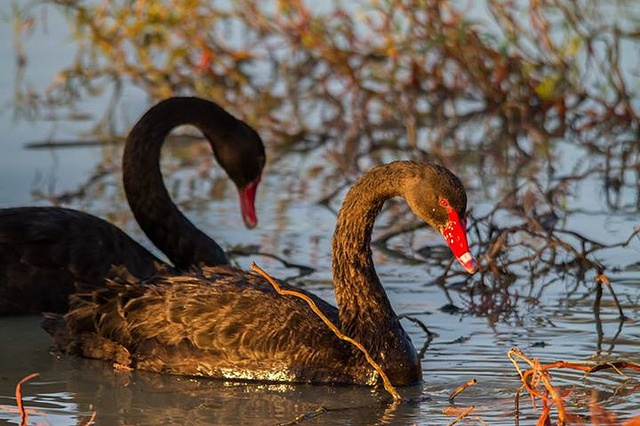Describe the objects in this image and their specific colors. I can see bird in darkgray, black, maroon, and brown tones and bird in darkgray, black, maroon, and gray tones in this image. 